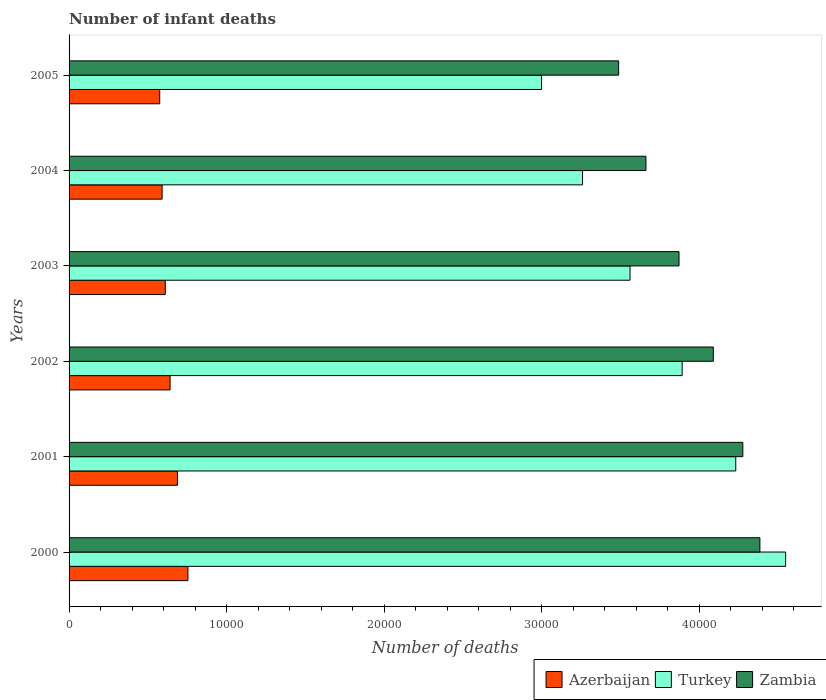Are the number of bars per tick equal to the number of legend labels?
Your answer should be compact. Yes. Are the number of bars on each tick of the Y-axis equal?
Your answer should be compact. Yes. What is the number of infant deaths in Azerbaijan in 2003?
Make the answer very short. 6107. Across all years, what is the maximum number of infant deaths in Azerbaijan?
Keep it short and to the point. 7545. Across all years, what is the minimum number of infant deaths in Zambia?
Offer a very short reply. 3.49e+04. In which year was the number of infant deaths in Zambia minimum?
Your answer should be compact. 2005. What is the total number of infant deaths in Zambia in the graph?
Provide a short and direct response. 2.38e+05. What is the difference between the number of infant deaths in Zambia in 2001 and that in 2002?
Provide a short and direct response. 1873. What is the difference between the number of infant deaths in Turkey in 2000 and the number of infant deaths in Azerbaijan in 2001?
Your response must be concise. 3.86e+04. What is the average number of infant deaths in Zambia per year?
Provide a short and direct response. 3.96e+04. In the year 2004, what is the difference between the number of infant deaths in Azerbaijan and number of infant deaths in Turkey?
Offer a very short reply. -2.67e+04. What is the ratio of the number of infant deaths in Turkey in 2002 to that in 2004?
Provide a succinct answer. 1.19. What is the difference between the highest and the second highest number of infant deaths in Azerbaijan?
Provide a succinct answer. 667. What is the difference between the highest and the lowest number of infant deaths in Azerbaijan?
Your answer should be compact. 1791. Is it the case that in every year, the sum of the number of infant deaths in Azerbaijan and number of infant deaths in Turkey is greater than the number of infant deaths in Zambia?
Provide a succinct answer. Yes. Are all the bars in the graph horizontal?
Make the answer very short. Yes. How many years are there in the graph?
Provide a short and direct response. 6. Are the values on the major ticks of X-axis written in scientific E-notation?
Provide a short and direct response. No. Does the graph contain grids?
Ensure brevity in your answer.  No. How many legend labels are there?
Provide a short and direct response. 3. What is the title of the graph?
Make the answer very short. Number of infant deaths. What is the label or title of the X-axis?
Your response must be concise. Number of deaths. What is the Number of deaths in Azerbaijan in 2000?
Your response must be concise. 7545. What is the Number of deaths of Turkey in 2000?
Keep it short and to the point. 4.55e+04. What is the Number of deaths in Zambia in 2000?
Ensure brevity in your answer.  4.38e+04. What is the Number of deaths of Azerbaijan in 2001?
Provide a succinct answer. 6878. What is the Number of deaths in Turkey in 2001?
Provide a short and direct response. 4.23e+04. What is the Number of deaths of Zambia in 2001?
Offer a very short reply. 4.28e+04. What is the Number of deaths in Azerbaijan in 2002?
Provide a succinct answer. 6412. What is the Number of deaths in Turkey in 2002?
Provide a short and direct response. 3.89e+04. What is the Number of deaths of Zambia in 2002?
Offer a terse response. 4.09e+04. What is the Number of deaths in Azerbaijan in 2003?
Ensure brevity in your answer.  6107. What is the Number of deaths in Turkey in 2003?
Offer a very short reply. 3.56e+04. What is the Number of deaths of Zambia in 2003?
Offer a terse response. 3.87e+04. What is the Number of deaths in Azerbaijan in 2004?
Your answer should be very brief. 5906. What is the Number of deaths in Turkey in 2004?
Ensure brevity in your answer.  3.26e+04. What is the Number of deaths of Zambia in 2004?
Your answer should be very brief. 3.66e+04. What is the Number of deaths of Azerbaijan in 2005?
Provide a succinct answer. 5754. What is the Number of deaths in Turkey in 2005?
Your answer should be compact. 3.00e+04. What is the Number of deaths in Zambia in 2005?
Your response must be concise. 3.49e+04. Across all years, what is the maximum Number of deaths of Azerbaijan?
Your answer should be very brief. 7545. Across all years, what is the maximum Number of deaths of Turkey?
Offer a very short reply. 4.55e+04. Across all years, what is the maximum Number of deaths in Zambia?
Provide a short and direct response. 4.38e+04. Across all years, what is the minimum Number of deaths in Azerbaijan?
Your answer should be compact. 5754. Across all years, what is the minimum Number of deaths of Turkey?
Make the answer very short. 3.00e+04. Across all years, what is the minimum Number of deaths of Zambia?
Offer a very short reply. 3.49e+04. What is the total Number of deaths of Azerbaijan in the graph?
Give a very brief answer. 3.86e+04. What is the total Number of deaths of Turkey in the graph?
Your answer should be compact. 2.25e+05. What is the total Number of deaths of Zambia in the graph?
Keep it short and to the point. 2.38e+05. What is the difference between the Number of deaths of Azerbaijan in 2000 and that in 2001?
Offer a terse response. 667. What is the difference between the Number of deaths in Turkey in 2000 and that in 2001?
Keep it short and to the point. 3167. What is the difference between the Number of deaths of Zambia in 2000 and that in 2001?
Offer a terse response. 1083. What is the difference between the Number of deaths of Azerbaijan in 2000 and that in 2002?
Your answer should be very brief. 1133. What is the difference between the Number of deaths of Turkey in 2000 and that in 2002?
Provide a short and direct response. 6570. What is the difference between the Number of deaths in Zambia in 2000 and that in 2002?
Your answer should be very brief. 2956. What is the difference between the Number of deaths of Azerbaijan in 2000 and that in 2003?
Keep it short and to the point. 1438. What is the difference between the Number of deaths in Turkey in 2000 and that in 2003?
Your response must be concise. 9880. What is the difference between the Number of deaths in Zambia in 2000 and that in 2003?
Your response must be concise. 5133. What is the difference between the Number of deaths of Azerbaijan in 2000 and that in 2004?
Provide a succinct answer. 1639. What is the difference between the Number of deaths of Turkey in 2000 and that in 2004?
Your response must be concise. 1.29e+04. What is the difference between the Number of deaths of Zambia in 2000 and that in 2004?
Your answer should be compact. 7232. What is the difference between the Number of deaths in Azerbaijan in 2000 and that in 2005?
Provide a succinct answer. 1791. What is the difference between the Number of deaths in Turkey in 2000 and that in 2005?
Your answer should be compact. 1.55e+04. What is the difference between the Number of deaths of Zambia in 2000 and that in 2005?
Offer a very short reply. 8966. What is the difference between the Number of deaths in Azerbaijan in 2001 and that in 2002?
Give a very brief answer. 466. What is the difference between the Number of deaths of Turkey in 2001 and that in 2002?
Keep it short and to the point. 3403. What is the difference between the Number of deaths in Zambia in 2001 and that in 2002?
Your answer should be very brief. 1873. What is the difference between the Number of deaths of Azerbaijan in 2001 and that in 2003?
Give a very brief answer. 771. What is the difference between the Number of deaths of Turkey in 2001 and that in 2003?
Make the answer very short. 6713. What is the difference between the Number of deaths of Zambia in 2001 and that in 2003?
Offer a terse response. 4050. What is the difference between the Number of deaths in Azerbaijan in 2001 and that in 2004?
Your response must be concise. 972. What is the difference between the Number of deaths of Turkey in 2001 and that in 2004?
Ensure brevity in your answer.  9726. What is the difference between the Number of deaths of Zambia in 2001 and that in 2004?
Ensure brevity in your answer.  6149. What is the difference between the Number of deaths in Azerbaijan in 2001 and that in 2005?
Offer a very short reply. 1124. What is the difference between the Number of deaths of Turkey in 2001 and that in 2005?
Offer a terse response. 1.23e+04. What is the difference between the Number of deaths of Zambia in 2001 and that in 2005?
Provide a succinct answer. 7883. What is the difference between the Number of deaths of Azerbaijan in 2002 and that in 2003?
Ensure brevity in your answer.  305. What is the difference between the Number of deaths in Turkey in 2002 and that in 2003?
Your response must be concise. 3310. What is the difference between the Number of deaths of Zambia in 2002 and that in 2003?
Give a very brief answer. 2177. What is the difference between the Number of deaths in Azerbaijan in 2002 and that in 2004?
Provide a short and direct response. 506. What is the difference between the Number of deaths in Turkey in 2002 and that in 2004?
Your response must be concise. 6323. What is the difference between the Number of deaths in Zambia in 2002 and that in 2004?
Offer a terse response. 4276. What is the difference between the Number of deaths in Azerbaijan in 2002 and that in 2005?
Make the answer very short. 658. What is the difference between the Number of deaths of Turkey in 2002 and that in 2005?
Your response must be concise. 8923. What is the difference between the Number of deaths in Zambia in 2002 and that in 2005?
Give a very brief answer. 6010. What is the difference between the Number of deaths in Azerbaijan in 2003 and that in 2004?
Provide a succinct answer. 201. What is the difference between the Number of deaths in Turkey in 2003 and that in 2004?
Provide a succinct answer. 3013. What is the difference between the Number of deaths of Zambia in 2003 and that in 2004?
Your answer should be compact. 2099. What is the difference between the Number of deaths in Azerbaijan in 2003 and that in 2005?
Keep it short and to the point. 353. What is the difference between the Number of deaths of Turkey in 2003 and that in 2005?
Ensure brevity in your answer.  5613. What is the difference between the Number of deaths in Zambia in 2003 and that in 2005?
Keep it short and to the point. 3833. What is the difference between the Number of deaths in Azerbaijan in 2004 and that in 2005?
Your response must be concise. 152. What is the difference between the Number of deaths in Turkey in 2004 and that in 2005?
Make the answer very short. 2600. What is the difference between the Number of deaths of Zambia in 2004 and that in 2005?
Your answer should be compact. 1734. What is the difference between the Number of deaths in Azerbaijan in 2000 and the Number of deaths in Turkey in 2001?
Your response must be concise. -3.48e+04. What is the difference between the Number of deaths of Azerbaijan in 2000 and the Number of deaths of Zambia in 2001?
Offer a terse response. -3.52e+04. What is the difference between the Number of deaths of Turkey in 2000 and the Number of deaths of Zambia in 2001?
Give a very brief answer. 2719. What is the difference between the Number of deaths of Azerbaijan in 2000 and the Number of deaths of Turkey in 2002?
Make the answer very short. -3.14e+04. What is the difference between the Number of deaths in Azerbaijan in 2000 and the Number of deaths in Zambia in 2002?
Offer a very short reply. -3.33e+04. What is the difference between the Number of deaths in Turkey in 2000 and the Number of deaths in Zambia in 2002?
Your answer should be compact. 4592. What is the difference between the Number of deaths in Azerbaijan in 2000 and the Number of deaths in Turkey in 2003?
Give a very brief answer. -2.81e+04. What is the difference between the Number of deaths of Azerbaijan in 2000 and the Number of deaths of Zambia in 2003?
Offer a very short reply. -3.12e+04. What is the difference between the Number of deaths of Turkey in 2000 and the Number of deaths of Zambia in 2003?
Keep it short and to the point. 6769. What is the difference between the Number of deaths of Azerbaijan in 2000 and the Number of deaths of Turkey in 2004?
Your answer should be compact. -2.50e+04. What is the difference between the Number of deaths in Azerbaijan in 2000 and the Number of deaths in Zambia in 2004?
Make the answer very short. -2.91e+04. What is the difference between the Number of deaths in Turkey in 2000 and the Number of deaths in Zambia in 2004?
Offer a very short reply. 8868. What is the difference between the Number of deaths in Azerbaijan in 2000 and the Number of deaths in Turkey in 2005?
Your answer should be very brief. -2.24e+04. What is the difference between the Number of deaths of Azerbaijan in 2000 and the Number of deaths of Zambia in 2005?
Your answer should be very brief. -2.73e+04. What is the difference between the Number of deaths in Turkey in 2000 and the Number of deaths in Zambia in 2005?
Your answer should be very brief. 1.06e+04. What is the difference between the Number of deaths of Azerbaijan in 2001 and the Number of deaths of Turkey in 2002?
Give a very brief answer. -3.20e+04. What is the difference between the Number of deaths of Azerbaijan in 2001 and the Number of deaths of Zambia in 2002?
Your answer should be compact. -3.40e+04. What is the difference between the Number of deaths of Turkey in 2001 and the Number of deaths of Zambia in 2002?
Keep it short and to the point. 1425. What is the difference between the Number of deaths in Azerbaijan in 2001 and the Number of deaths in Turkey in 2003?
Provide a short and direct response. -2.87e+04. What is the difference between the Number of deaths in Azerbaijan in 2001 and the Number of deaths in Zambia in 2003?
Give a very brief answer. -3.18e+04. What is the difference between the Number of deaths of Turkey in 2001 and the Number of deaths of Zambia in 2003?
Provide a succinct answer. 3602. What is the difference between the Number of deaths in Azerbaijan in 2001 and the Number of deaths in Turkey in 2004?
Offer a very short reply. -2.57e+04. What is the difference between the Number of deaths of Azerbaijan in 2001 and the Number of deaths of Zambia in 2004?
Provide a short and direct response. -2.97e+04. What is the difference between the Number of deaths of Turkey in 2001 and the Number of deaths of Zambia in 2004?
Offer a terse response. 5701. What is the difference between the Number of deaths of Azerbaijan in 2001 and the Number of deaths of Turkey in 2005?
Your answer should be very brief. -2.31e+04. What is the difference between the Number of deaths in Azerbaijan in 2001 and the Number of deaths in Zambia in 2005?
Provide a succinct answer. -2.80e+04. What is the difference between the Number of deaths in Turkey in 2001 and the Number of deaths in Zambia in 2005?
Offer a very short reply. 7435. What is the difference between the Number of deaths of Azerbaijan in 2002 and the Number of deaths of Turkey in 2003?
Ensure brevity in your answer.  -2.92e+04. What is the difference between the Number of deaths of Azerbaijan in 2002 and the Number of deaths of Zambia in 2003?
Provide a short and direct response. -3.23e+04. What is the difference between the Number of deaths in Turkey in 2002 and the Number of deaths in Zambia in 2003?
Make the answer very short. 199. What is the difference between the Number of deaths of Azerbaijan in 2002 and the Number of deaths of Turkey in 2004?
Make the answer very short. -2.62e+04. What is the difference between the Number of deaths of Azerbaijan in 2002 and the Number of deaths of Zambia in 2004?
Your answer should be very brief. -3.02e+04. What is the difference between the Number of deaths in Turkey in 2002 and the Number of deaths in Zambia in 2004?
Provide a short and direct response. 2298. What is the difference between the Number of deaths of Azerbaijan in 2002 and the Number of deaths of Turkey in 2005?
Give a very brief answer. -2.36e+04. What is the difference between the Number of deaths in Azerbaijan in 2002 and the Number of deaths in Zambia in 2005?
Ensure brevity in your answer.  -2.85e+04. What is the difference between the Number of deaths in Turkey in 2002 and the Number of deaths in Zambia in 2005?
Your answer should be compact. 4032. What is the difference between the Number of deaths of Azerbaijan in 2003 and the Number of deaths of Turkey in 2004?
Ensure brevity in your answer.  -2.65e+04. What is the difference between the Number of deaths in Azerbaijan in 2003 and the Number of deaths in Zambia in 2004?
Offer a terse response. -3.05e+04. What is the difference between the Number of deaths in Turkey in 2003 and the Number of deaths in Zambia in 2004?
Offer a terse response. -1012. What is the difference between the Number of deaths in Azerbaijan in 2003 and the Number of deaths in Turkey in 2005?
Keep it short and to the point. -2.39e+04. What is the difference between the Number of deaths in Azerbaijan in 2003 and the Number of deaths in Zambia in 2005?
Give a very brief answer. -2.88e+04. What is the difference between the Number of deaths of Turkey in 2003 and the Number of deaths of Zambia in 2005?
Ensure brevity in your answer.  722. What is the difference between the Number of deaths in Azerbaijan in 2004 and the Number of deaths in Turkey in 2005?
Keep it short and to the point. -2.41e+04. What is the difference between the Number of deaths in Azerbaijan in 2004 and the Number of deaths in Zambia in 2005?
Keep it short and to the point. -2.90e+04. What is the difference between the Number of deaths in Turkey in 2004 and the Number of deaths in Zambia in 2005?
Provide a short and direct response. -2291. What is the average Number of deaths of Azerbaijan per year?
Give a very brief answer. 6433.67. What is the average Number of deaths in Turkey per year?
Offer a very short reply. 3.75e+04. What is the average Number of deaths of Zambia per year?
Ensure brevity in your answer.  3.96e+04. In the year 2000, what is the difference between the Number of deaths in Azerbaijan and Number of deaths in Turkey?
Provide a short and direct response. -3.79e+04. In the year 2000, what is the difference between the Number of deaths of Azerbaijan and Number of deaths of Zambia?
Your answer should be compact. -3.63e+04. In the year 2000, what is the difference between the Number of deaths of Turkey and Number of deaths of Zambia?
Your answer should be compact. 1636. In the year 2001, what is the difference between the Number of deaths in Azerbaijan and Number of deaths in Turkey?
Your answer should be compact. -3.54e+04. In the year 2001, what is the difference between the Number of deaths of Azerbaijan and Number of deaths of Zambia?
Offer a very short reply. -3.59e+04. In the year 2001, what is the difference between the Number of deaths of Turkey and Number of deaths of Zambia?
Offer a terse response. -448. In the year 2002, what is the difference between the Number of deaths in Azerbaijan and Number of deaths in Turkey?
Keep it short and to the point. -3.25e+04. In the year 2002, what is the difference between the Number of deaths in Azerbaijan and Number of deaths in Zambia?
Keep it short and to the point. -3.45e+04. In the year 2002, what is the difference between the Number of deaths in Turkey and Number of deaths in Zambia?
Your answer should be compact. -1978. In the year 2003, what is the difference between the Number of deaths of Azerbaijan and Number of deaths of Turkey?
Offer a very short reply. -2.95e+04. In the year 2003, what is the difference between the Number of deaths of Azerbaijan and Number of deaths of Zambia?
Your answer should be compact. -3.26e+04. In the year 2003, what is the difference between the Number of deaths in Turkey and Number of deaths in Zambia?
Provide a short and direct response. -3111. In the year 2004, what is the difference between the Number of deaths of Azerbaijan and Number of deaths of Turkey?
Ensure brevity in your answer.  -2.67e+04. In the year 2004, what is the difference between the Number of deaths in Azerbaijan and Number of deaths in Zambia?
Ensure brevity in your answer.  -3.07e+04. In the year 2004, what is the difference between the Number of deaths in Turkey and Number of deaths in Zambia?
Provide a succinct answer. -4025. In the year 2005, what is the difference between the Number of deaths of Azerbaijan and Number of deaths of Turkey?
Offer a terse response. -2.42e+04. In the year 2005, what is the difference between the Number of deaths of Azerbaijan and Number of deaths of Zambia?
Provide a succinct answer. -2.91e+04. In the year 2005, what is the difference between the Number of deaths of Turkey and Number of deaths of Zambia?
Provide a succinct answer. -4891. What is the ratio of the Number of deaths of Azerbaijan in 2000 to that in 2001?
Keep it short and to the point. 1.1. What is the ratio of the Number of deaths of Turkey in 2000 to that in 2001?
Your answer should be very brief. 1.07. What is the ratio of the Number of deaths of Zambia in 2000 to that in 2001?
Offer a terse response. 1.03. What is the ratio of the Number of deaths in Azerbaijan in 2000 to that in 2002?
Make the answer very short. 1.18. What is the ratio of the Number of deaths of Turkey in 2000 to that in 2002?
Your answer should be very brief. 1.17. What is the ratio of the Number of deaths of Zambia in 2000 to that in 2002?
Your answer should be compact. 1.07. What is the ratio of the Number of deaths of Azerbaijan in 2000 to that in 2003?
Provide a succinct answer. 1.24. What is the ratio of the Number of deaths of Turkey in 2000 to that in 2003?
Provide a short and direct response. 1.28. What is the ratio of the Number of deaths in Zambia in 2000 to that in 2003?
Make the answer very short. 1.13. What is the ratio of the Number of deaths in Azerbaijan in 2000 to that in 2004?
Your response must be concise. 1.28. What is the ratio of the Number of deaths in Turkey in 2000 to that in 2004?
Your response must be concise. 1.4. What is the ratio of the Number of deaths of Zambia in 2000 to that in 2004?
Give a very brief answer. 1.2. What is the ratio of the Number of deaths of Azerbaijan in 2000 to that in 2005?
Make the answer very short. 1.31. What is the ratio of the Number of deaths in Turkey in 2000 to that in 2005?
Your answer should be compact. 1.52. What is the ratio of the Number of deaths in Zambia in 2000 to that in 2005?
Your answer should be very brief. 1.26. What is the ratio of the Number of deaths of Azerbaijan in 2001 to that in 2002?
Your response must be concise. 1.07. What is the ratio of the Number of deaths in Turkey in 2001 to that in 2002?
Your answer should be very brief. 1.09. What is the ratio of the Number of deaths in Zambia in 2001 to that in 2002?
Offer a terse response. 1.05. What is the ratio of the Number of deaths in Azerbaijan in 2001 to that in 2003?
Your answer should be very brief. 1.13. What is the ratio of the Number of deaths of Turkey in 2001 to that in 2003?
Make the answer very short. 1.19. What is the ratio of the Number of deaths of Zambia in 2001 to that in 2003?
Make the answer very short. 1.1. What is the ratio of the Number of deaths of Azerbaijan in 2001 to that in 2004?
Offer a very short reply. 1.16. What is the ratio of the Number of deaths of Turkey in 2001 to that in 2004?
Provide a succinct answer. 1.3. What is the ratio of the Number of deaths in Zambia in 2001 to that in 2004?
Give a very brief answer. 1.17. What is the ratio of the Number of deaths of Azerbaijan in 2001 to that in 2005?
Provide a short and direct response. 1.2. What is the ratio of the Number of deaths of Turkey in 2001 to that in 2005?
Give a very brief answer. 1.41. What is the ratio of the Number of deaths in Zambia in 2001 to that in 2005?
Ensure brevity in your answer.  1.23. What is the ratio of the Number of deaths in Azerbaijan in 2002 to that in 2003?
Your answer should be compact. 1.05. What is the ratio of the Number of deaths of Turkey in 2002 to that in 2003?
Make the answer very short. 1.09. What is the ratio of the Number of deaths of Zambia in 2002 to that in 2003?
Your answer should be very brief. 1.06. What is the ratio of the Number of deaths in Azerbaijan in 2002 to that in 2004?
Ensure brevity in your answer.  1.09. What is the ratio of the Number of deaths in Turkey in 2002 to that in 2004?
Keep it short and to the point. 1.19. What is the ratio of the Number of deaths in Zambia in 2002 to that in 2004?
Your answer should be compact. 1.12. What is the ratio of the Number of deaths of Azerbaijan in 2002 to that in 2005?
Provide a succinct answer. 1.11. What is the ratio of the Number of deaths of Turkey in 2002 to that in 2005?
Your answer should be compact. 1.3. What is the ratio of the Number of deaths in Zambia in 2002 to that in 2005?
Ensure brevity in your answer.  1.17. What is the ratio of the Number of deaths of Azerbaijan in 2003 to that in 2004?
Keep it short and to the point. 1.03. What is the ratio of the Number of deaths in Turkey in 2003 to that in 2004?
Make the answer very short. 1.09. What is the ratio of the Number of deaths in Zambia in 2003 to that in 2004?
Offer a terse response. 1.06. What is the ratio of the Number of deaths of Azerbaijan in 2003 to that in 2005?
Your answer should be very brief. 1.06. What is the ratio of the Number of deaths of Turkey in 2003 to that in 2005?
Offer a terse response. 1.19. What is the ratio of the Number of deaths in Zambia in 2003 to that in 2005?
Your response must be concise. 1.11. What is the ratio of the Number of deaths of Azerbaijan in 2004 to that in 2005?
Keep it short and to the point. 1.03. What is the ratio of the Number of deaths of Turkey in 2004 to that in 2005?
Offer a very short reply. 1.09. What is the ratio of the Number of deaths of Zambia in 2004 to that in 2005?
Offer a terse response. 1.05. What is the difference between the highest and the second highest Number of deaths of Azerbaijan?
Offer a terse response. 667. What is the difference between the highest and the second highest Number of deaths of Turkey?
Offer a very short reply. 3167. What is the difference between the highest and the second highest Number of deaths in Zambia?
Provide a succinct answer. 1083. What is the difference between the highest and the lowest Number of deaths in Azerbaijan?
Offer a very short reply. 1791. What is the difference between the highest and the lowest Number of deaths in Turkey?
Offer a terse response. 1.55e+04. What is the difference between the highest and the lowest Number of deaths in Zambia?
Offer a very short reply. 8966. 